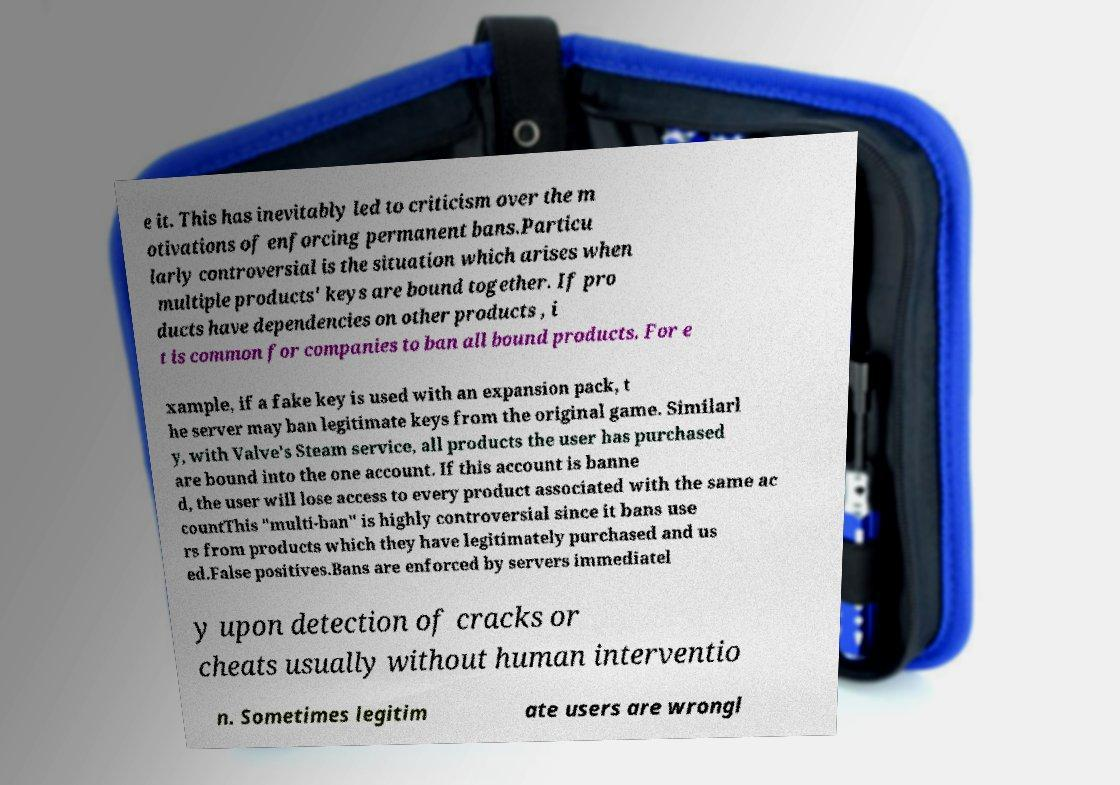Please read and relay the text visible in this image. What does it say? e it. This has inevitably led to criticism over the m otivations of enforcing permanent bans.Particu larly controversial is the situation which arises when multiple products' keys are bound together. If pro ducts have dependencies on other products , i t is common for companies to ban all bound products. For e xample, if a fake key is used with an expansion pack, t he server may ban legitimate keys from the original game. Similarl y, with Valve's Steam service, all products the user has purchased are bound into the one account. If this account is banne d, the user will lose access to every product associated with the same ac countThis "multi-ban" is highly controversial since it bans use rs from products which they have legitimately purchased and us ed.False positives.Bans are enforced by servers immediatel y upon detection of cracks or cheats usually without human interventio n. Sometimes legitim ate users are wrongl 